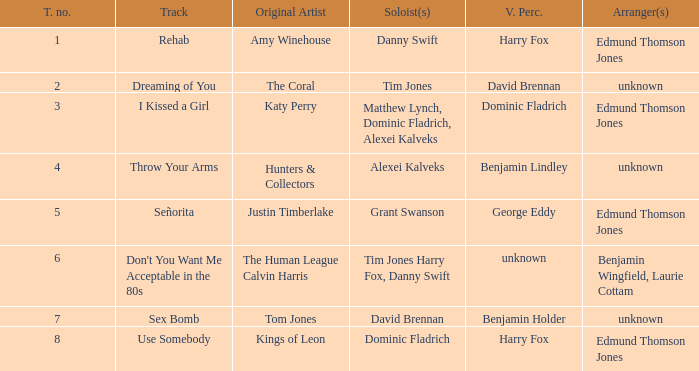Who is the vocal percussionist for Sex Bomb? Benjamin Holder. 